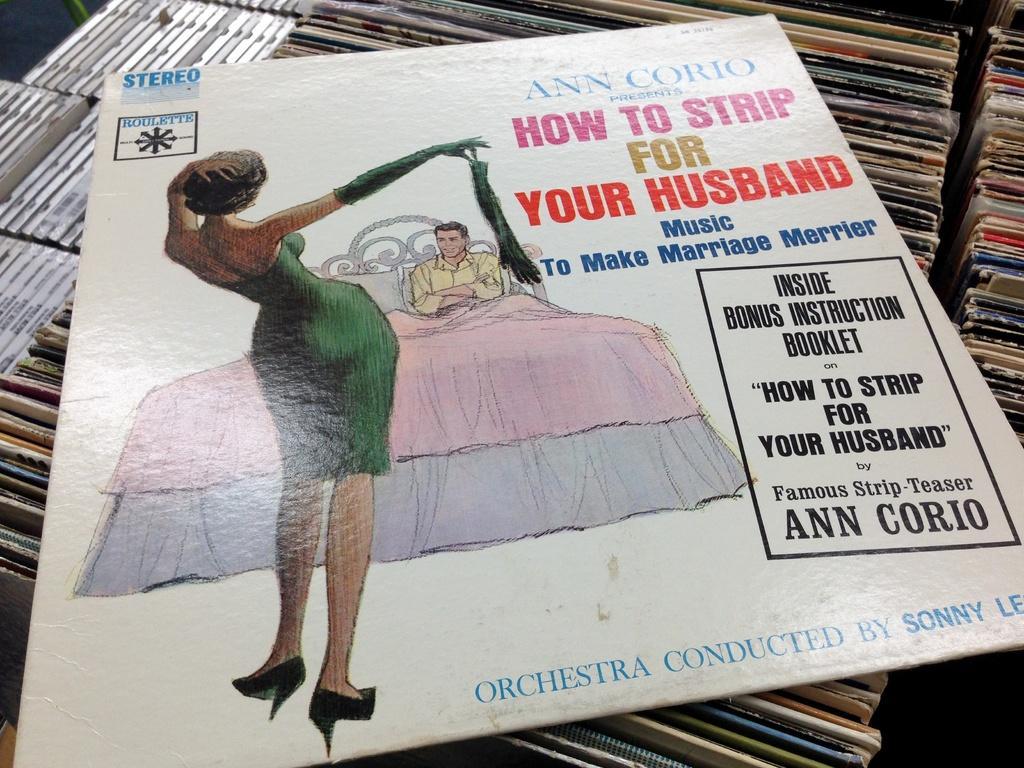In one or two sentences, can you explain what this image depicts? At the bottom of the image there are many books. In the middle of the image there is a board with a text on it. There is a woman and a man is lying on the bed. 